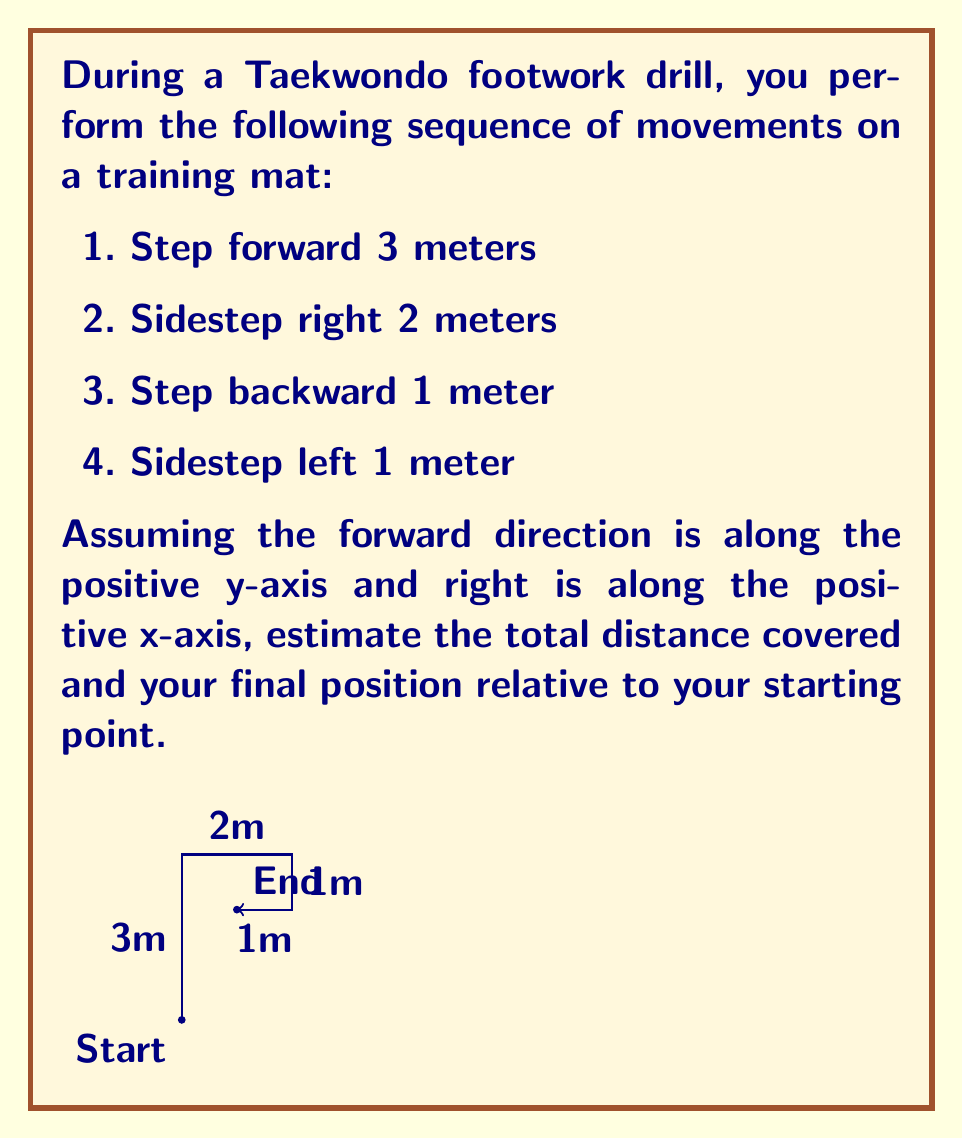Can you solve this math problem? Let's approach this step-by-step using vector addition:

1) First, let's represent each movement as a vector:
   - Forward 3m: $\vec{v_1} = (0, 3)$
   - Right 2m: $\vec{v_2} = (2, 0)$
   - Backward 1m: $\vec{v_3} = (0, -1)$
   - Left 1m: $\vec{v_4} = (-1, 0)$

2) The total displacement vector is the sum of these vectors:
   $\vec{v_{total}} = \vec{v_1} + \vec{v_2} + \vec{v_3} + \vec{v_4}$
   $\vec{v_{total}} = (0, 3) + (2, 0) + (0, -1) + (-1, 0)$
   $\vec{v_{total}} = (1, 2)$

3) This means your final position is 1 meter to the right and 2 meters forward from your starting point.

4) To calculate the total distance covered, we need to sum the magnitudes of each movement:
   Total distance = $3 + 2 + 1 + 1 = 7$ meters

5) To find the straight-line distance from start to end (magnitude of $\vec{v_{total}}$):
   $\|\vec{v_{total}}\| = \sqrt{1^2 + 2^2} = \sqrt{5} \approx 2.24$ meters

Therefore, you covered a total distance of 7 meters, but ended up approximately 2.24 meters away from your starting point, at the position (1, 2) relative to your start.
Answer: Total distance covered: 7m. Final position: (1, 2). Straight-line distance from start: $\sqrt{5}$ m ≈ 2.24m. 